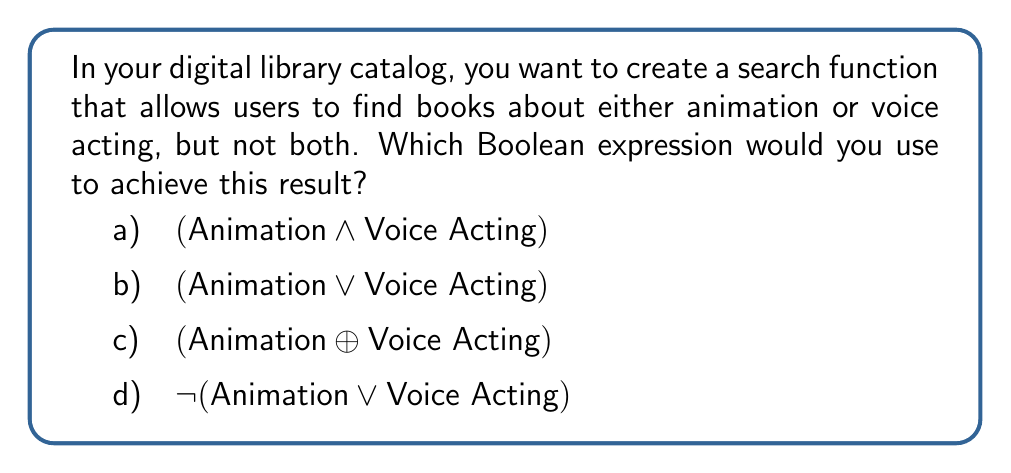Give your solution to this math problem. Let's approach this step-by-step:

1) First, let's understand what each Boolean operator means:
   $\land$ (AND): Both conditions must be true
   $\lor$ (OR): At least one condition must be true
   $\oplus$ (XOR): Exactly one condition must be true
   $\lnot$ (NOT): Negates the condition

2) We want books about animation OR voice acting, but not both. This is the definition of the XOR (exclusive OR) operation.

3) Let's evaluate each option:
   a) $(\text{Animation} \land \text{Voice Acting})$: This would return books that are about BOTH animation AND voice acting, which is not what we want.
   
   b) $(\text{Animation} \lor \text{Voice Acting})$: This would return books about animation OR voice acting OR both, which includes more than we want.
   
   c) $(\text{Animation} \oplus \text{Voice Acting})$: This would return books about animation OR voice acting, but NOT both. This matches our requirements.
   
   d) $\lnot(\text{Animation} \lor \text{Voice Acting})$: This would return books that are neither about animation NOR voice acting, which is the opposite of what we want.

4) Therefore, the correct Boolean expression to use is the XOR operation, represented by option c.
Answer: c) $(\text{Animation} \oplus \text{Voice Acting})$ 